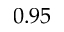Convert formula to latex. <formula><loc_0><loc_0><loc_500><loc_500>0 . 9 5</formula> 